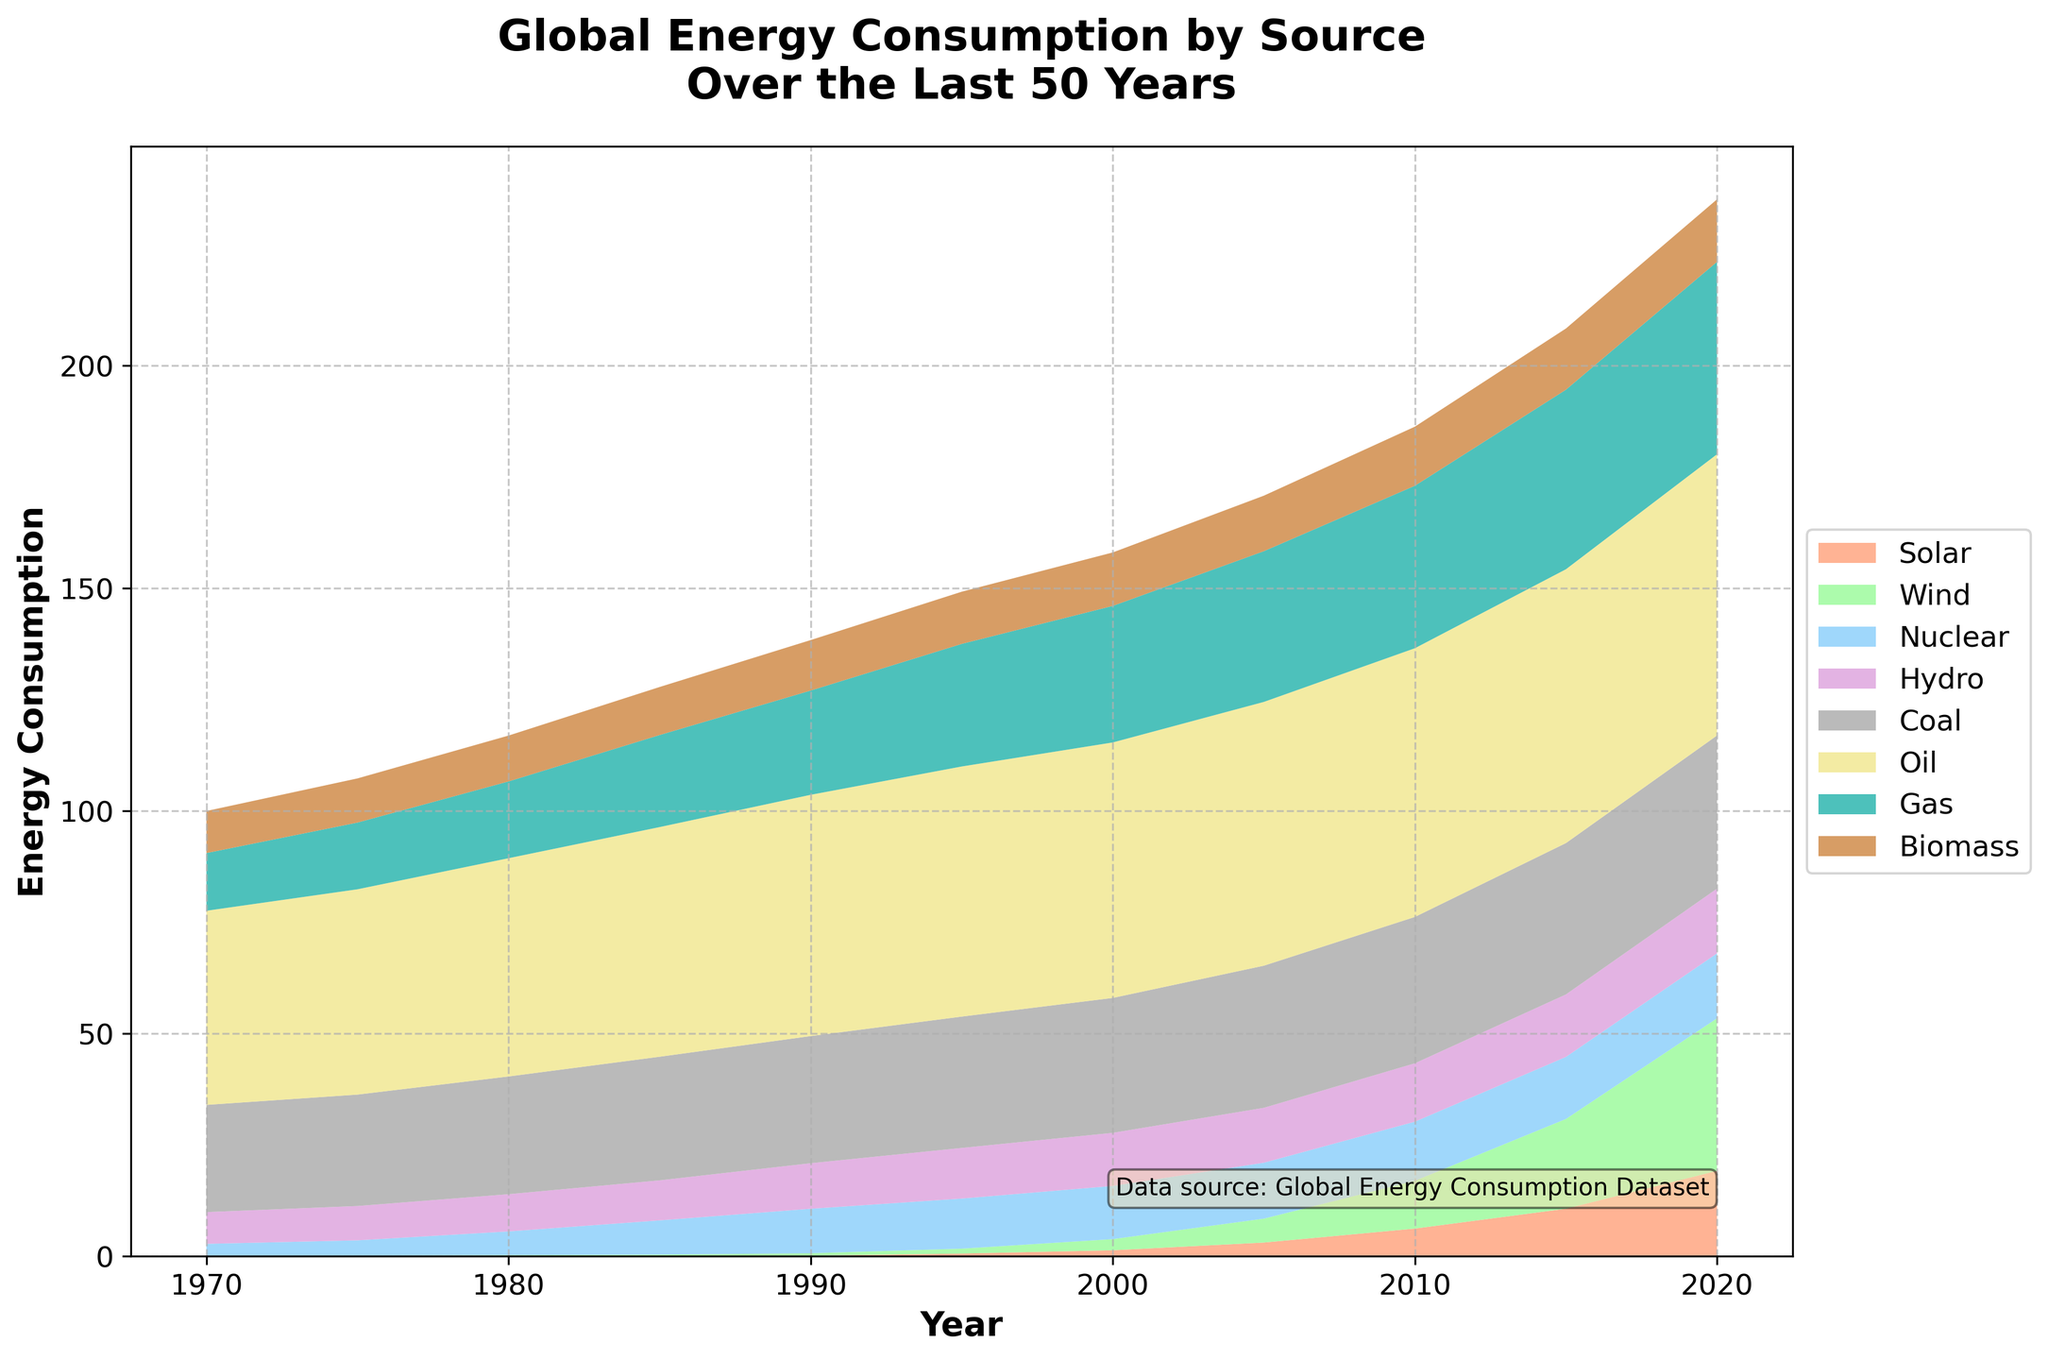What is the title of the plot? The title is located at the top of the plot and is usually written in a larger and bold font to make it stand out.
Answer: Global Energy Consumption by Source Over the Last 50 Years How many energy sources are displayed in the plot? Count the number of unique labels in the legend of the plot, each representing an energy source.
Answer: 8 Which energy source has seen the most significant increase from 1970 to 2020? By visually comparing the areas under each stack in 1970 and 2020, the energy source with the largest growth is identified.
Answer: Solar In which year did wind energy consumption significantly start to rise? Look for the point where the area representing wind energy begins to noticeably increase, this is typically a sharp turn upwards.
Answer: Around 2000 What was the approximate energy consumption of Oil in 2000? Locate the section for Oil in the area chart for the year 2000 and estimate its position on the y-axis.
Answer: 57.38 Which energy sources usage remained relatively stable compared to others throughout the 50 years? Identify the areas in the plot that show relatively small changes over time, staying relatively constant.
Answer: Biomass and Hydro How does the consumption of Nuclear energy in 1980 compare to that in 2020? Locate Nuclear consumption values/areas in the area chart for 1980 and 2020 and compare them to identify the trend.
Answer: Increased Which energy source had the lowest consumption consistently over the years? By looking at the areas of each source, identify the one with the smallest area throughout the plot duration.
Answer: Solar How did the consumption rates of Coal and Gas compare from 2015 to 2020? Examine the areas between 2015 and 2020 for Coal and Gas, then compare whether one is growing faster or if they are stable.
Answer: Gas increased more than Coal What is the trend in the consumption of Hydroelectric energy over the last 50 years? Observe the area representing Hydro throughout the time span and note whether it increased, decreased, or remained constant.
Answer: Slightly increased 